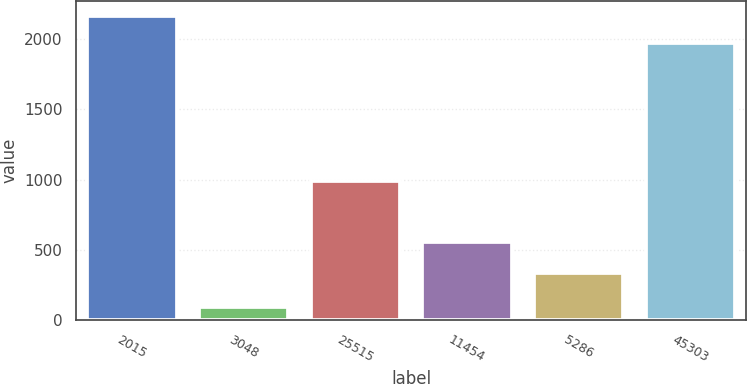<chart> <loc_0><loc_0><loc_500><loc_500><bar_chart><fcel>2015<fcel>3048<fcel>25515<fcel>11454<fcel>5286<fcel>45303<nl><fcel>2165.7<fcel>94<fcel>992<fcel>554<fcel>334<fcel>1974<nl></chart> 